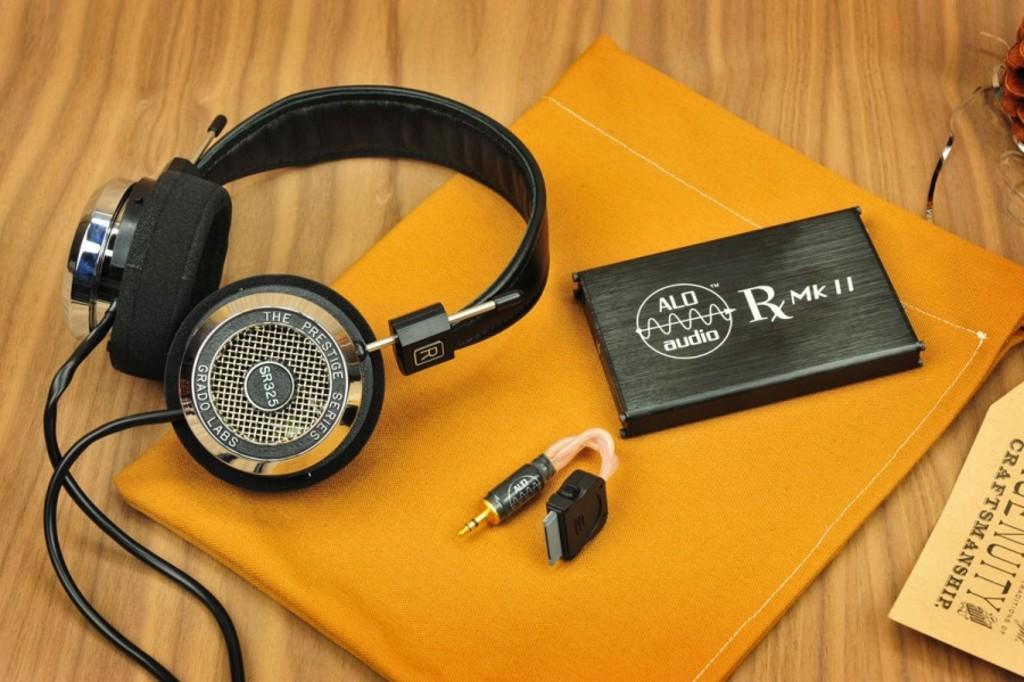What is the main object in the center of the image? There is a headset in the center of the image. What else can be seen in the image besides the headset? There is a book, a board, and a cloth in the image. What is the board used for in the image? The purpose of the board is not clear from the image, but it is present. What is the cloth used for in the image? The purpose of the cloth is not clear from the image, but it is present. What is the surface on which these objects are placed? There are objects on the table in the image. What type of sweater is the person wearing in the image? There is no person wearing a sweater in the image; it only features a headset, a book, a board, a cloth, and objects on a table. 